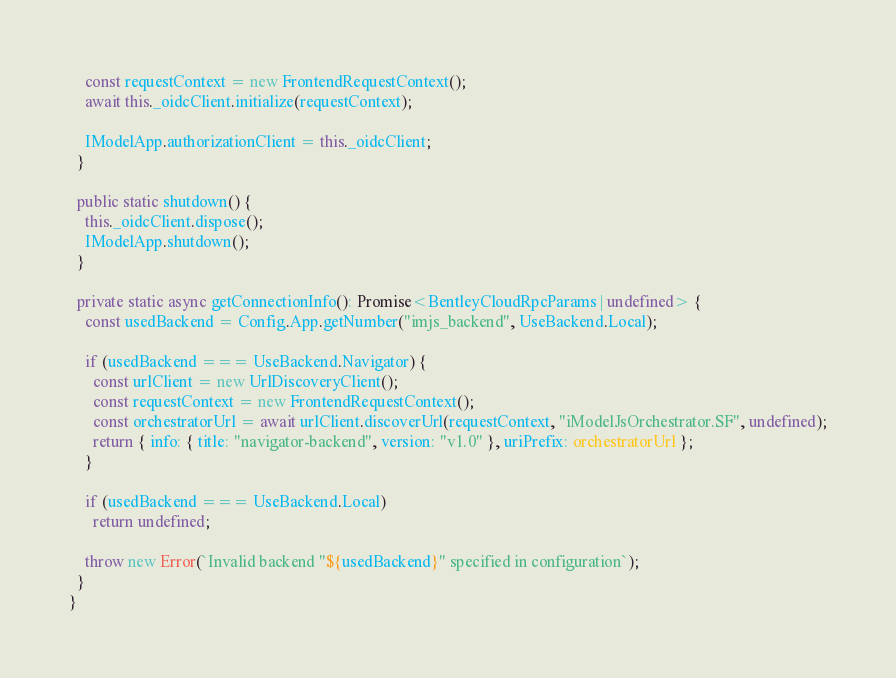Convert code to text. <code><loc_0><loc_0><loc_500><loc_500><_TypeScript_>    const requestContext = new FrontendRequestContext();
    await this._oidcClient.initialize(requestContext);

    IModelApp.authorizationClient = this._oidcClient;
  }

  public static shutdown() {
    this._oidcClient.dispose();
    IModelApp.shutdown();
  }

  private static async getConnectionInfo(): Promise<BentleyCloudRpcParams | undefined> {
    const usedBackend = Config.App.getNumber("imjs_backend", UseBackend.Local);

    if (usedBackend === UseBackend.Navigator) {
      const urlClient = new UrlDiscoveryClient();
      const requestContext = new FrontendRequestContext();
      const orchestratorUrl = await urlClient.discoverUrl(requestContext, "iModelJsOrchestrator.SF", undefined);
      return { info: { title: "navigator-backend", version: "v1.0" }, uriPrefix: orchestratorUrl };
    }

    if (usedBackend === UseBackend.Local)
      return undefined;

    throw new Error(`Invalid backend "${usedBackend}" specified in configuration`);
  }
}
</code> 